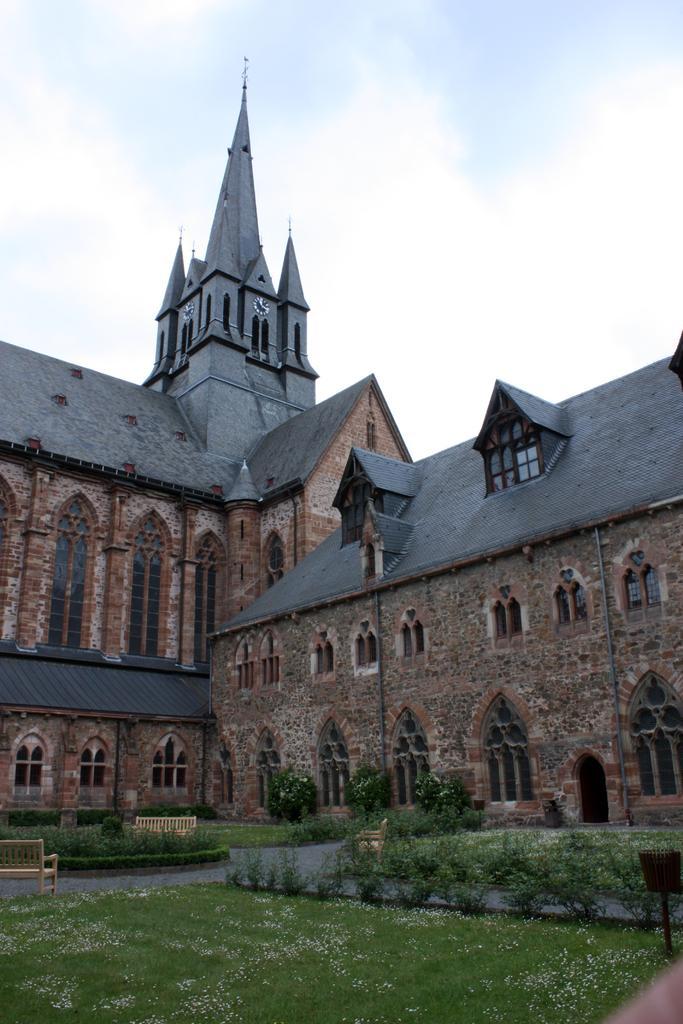In one or two sentences, can you explain what this image depicts? In the image there is a castle in the background with trees,plants in front of it and above its sky with clouds. 